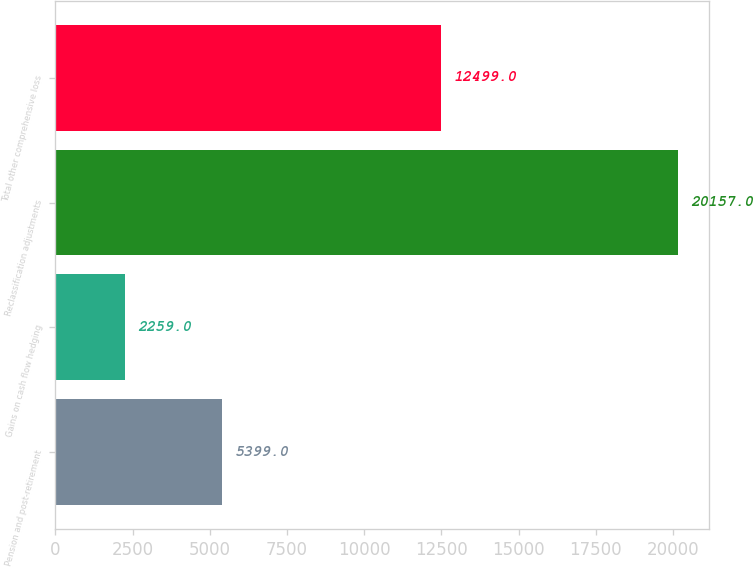<chart> <loc_0><loc_0><loc_500><loc_500><bar_chart><fcel>Pension and post-retirement<fcel>Gains on cash flow hedging<fcel>Reclassification adjustments<fcel>Total other comprehensive loss<nl><fcel>5399<fcel>2259<fcel>20157<fcel>12499<nl></chart> 